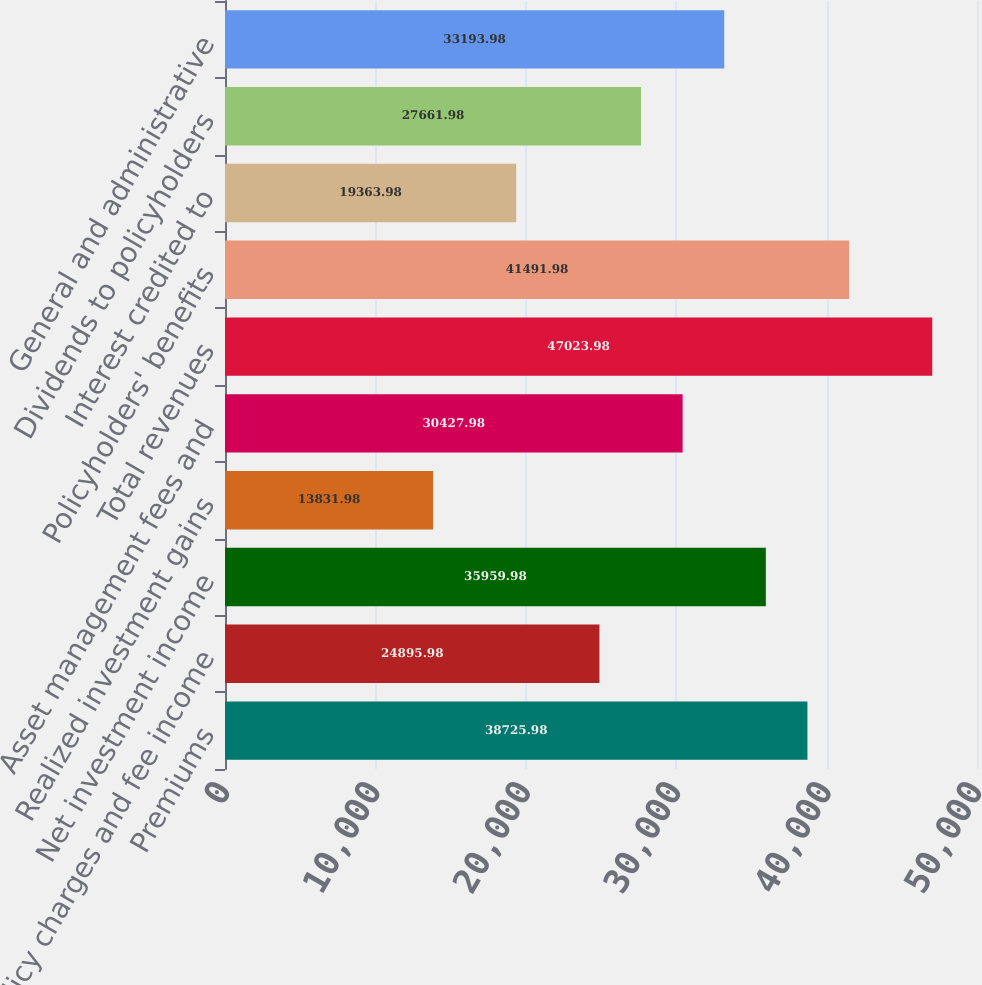<chart> <loc_0><loc_0><loc_500><loc_500><bar_chart><fcel>Premiums<fcel>Policy charges and fee income<fcel>Net investment income<fcel>Realized investment gains<fcel>Asset management fees and<fcel>Total revenues<fcel>Policyholders' benefits<fcel>Interest credited to<fcel>Dividends to policyholders<fcel>General and administrative<nl><fcel>38726<fcel>24896<fcel>35960<fcel>13832<fcel>30428<fcel>47024<fcel>41492<fcel>19364<fcel>27662<fcel>33194<nl></chart> 